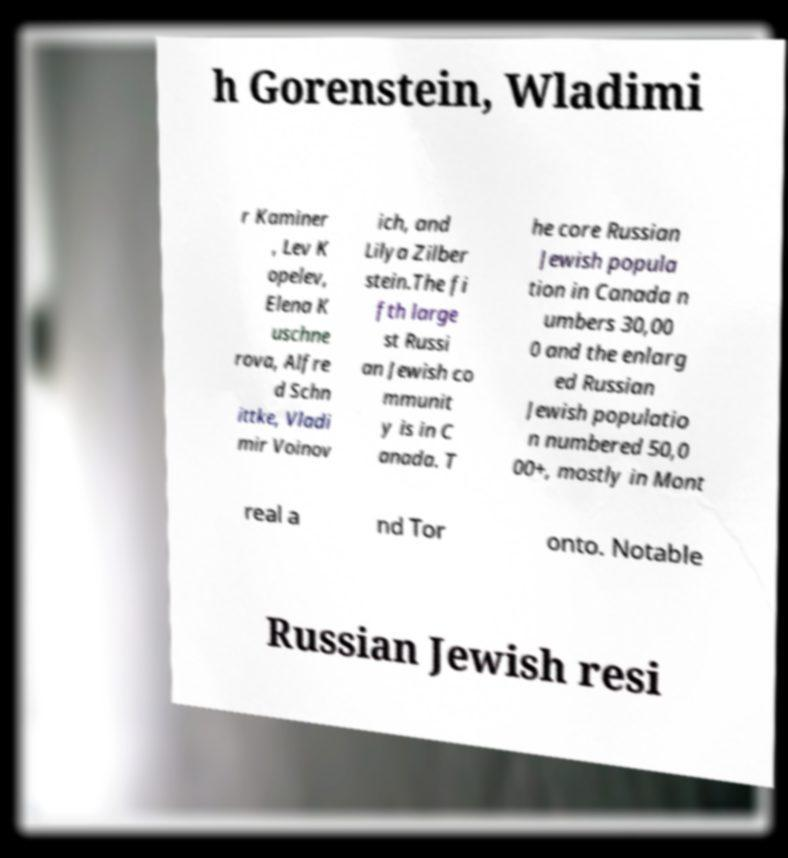For documentation purposes, I need the text within this image transcribed. Could you provide that? h Gorenstein, Wladimi r Kaminer , Lev K opelev, Elena K uschne rova, Alfre d Schn ittke, Vladi mir Voinov ich, and Lilya Zilber stein.The fi fth large st Russi an Jewish co mmunit y is in C anada. T he core Russian Jewish popula tion in Canada n umbers 30,00 0 and the enlarg ed Russian Jewish populatio n numbered 50,0 00+, mostly in Mont real a nd Tor onto. Notable Russian Jewish resi 